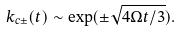Convert formula to latex. <formula><loc_0><loc_0><loc_500><loc_500>k _ { c \pm } ( t ) \sim \exp ( \pm \sqrt { 4 \Omega t / 3 } ) .</formula> 